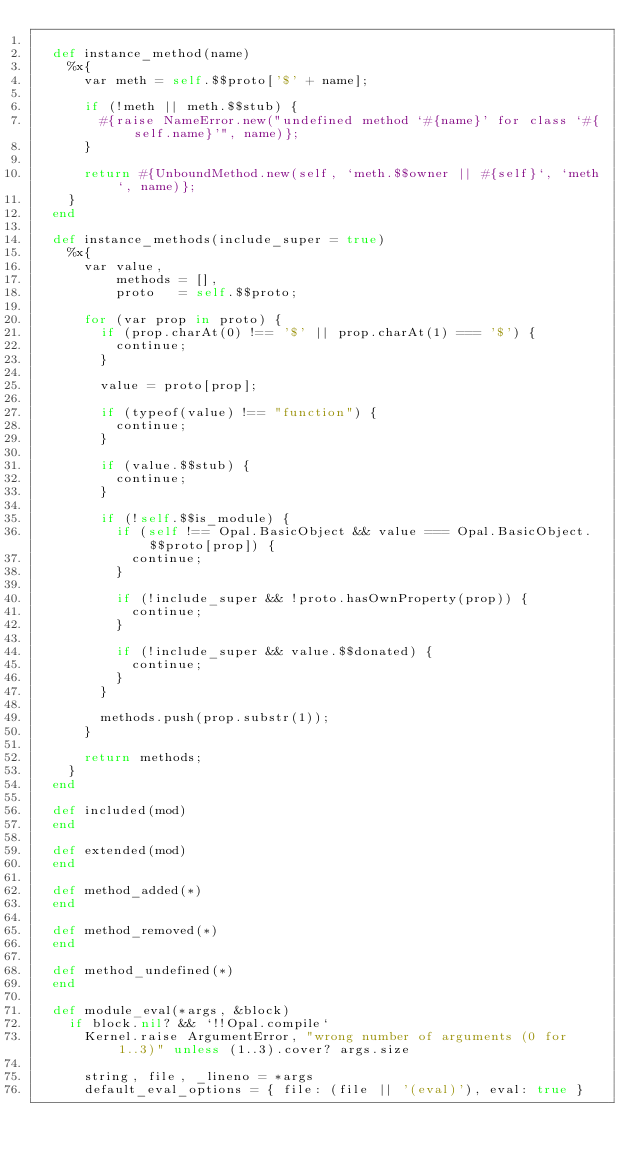Convert code to text. <code><loc_0><loc_0><loc_500><loc_500><_Ruby_>
  def instance_method(name)
    %x{
      var meth = self.$$proto['$' + name];

      if (!meth || meth.$$stub) {
        #{raise NameError.new("undefined method `#{name}' for class `#{self.name}'", name)};
      }

      return #{UnboundMethod.new(self, `meth.$$owner || #{self}`, `meth`, name)};
    }
  end

  def instance_methods(include_super = true)
    %x{
      var value,
          methods = [],
          proto   = self.$$proto;

      for (var prop in proto) {
        if (prop.charAt(0) !== '$' || prop.charAt(1) === '$') {
          continue;
        }

        value = proto[prop];

        if (typeof(value) !== "function") {
          continue;
        }

        if (value.$$stub) {
          continue;
        }

        if (!self.$$is_module) {
          if (self !== Opal.BasicObject && value === Opal.BasicObject.$$proto[prop]) {
            continue;
          }

          if (!include_super && !proto.hasOwnProperty(prop)) {
            continue;
          }

          if (!include_super && value.$$donated) {
            continue;
          }
        }

        methods.push(prop.substr(1));
      }

      return methods;
    }
  end

  def included(mod)
  end

  def extended(mod)
  end

  def method_added(*)
  end

  def method_removed(*)
  end

  def method_undefined(*)
  end

  def module_eval(*args, &block)
    if block.nil? && `!!Opal.compile`
      Kernel.raise ArgumentError, "wrong number of arguments (0 for 1..3)" unless (1..3).cover? args.size

      string, file, _lineno = *args
      default_eval_options = { file: (file || '(eval)'), eval: true }</code> 